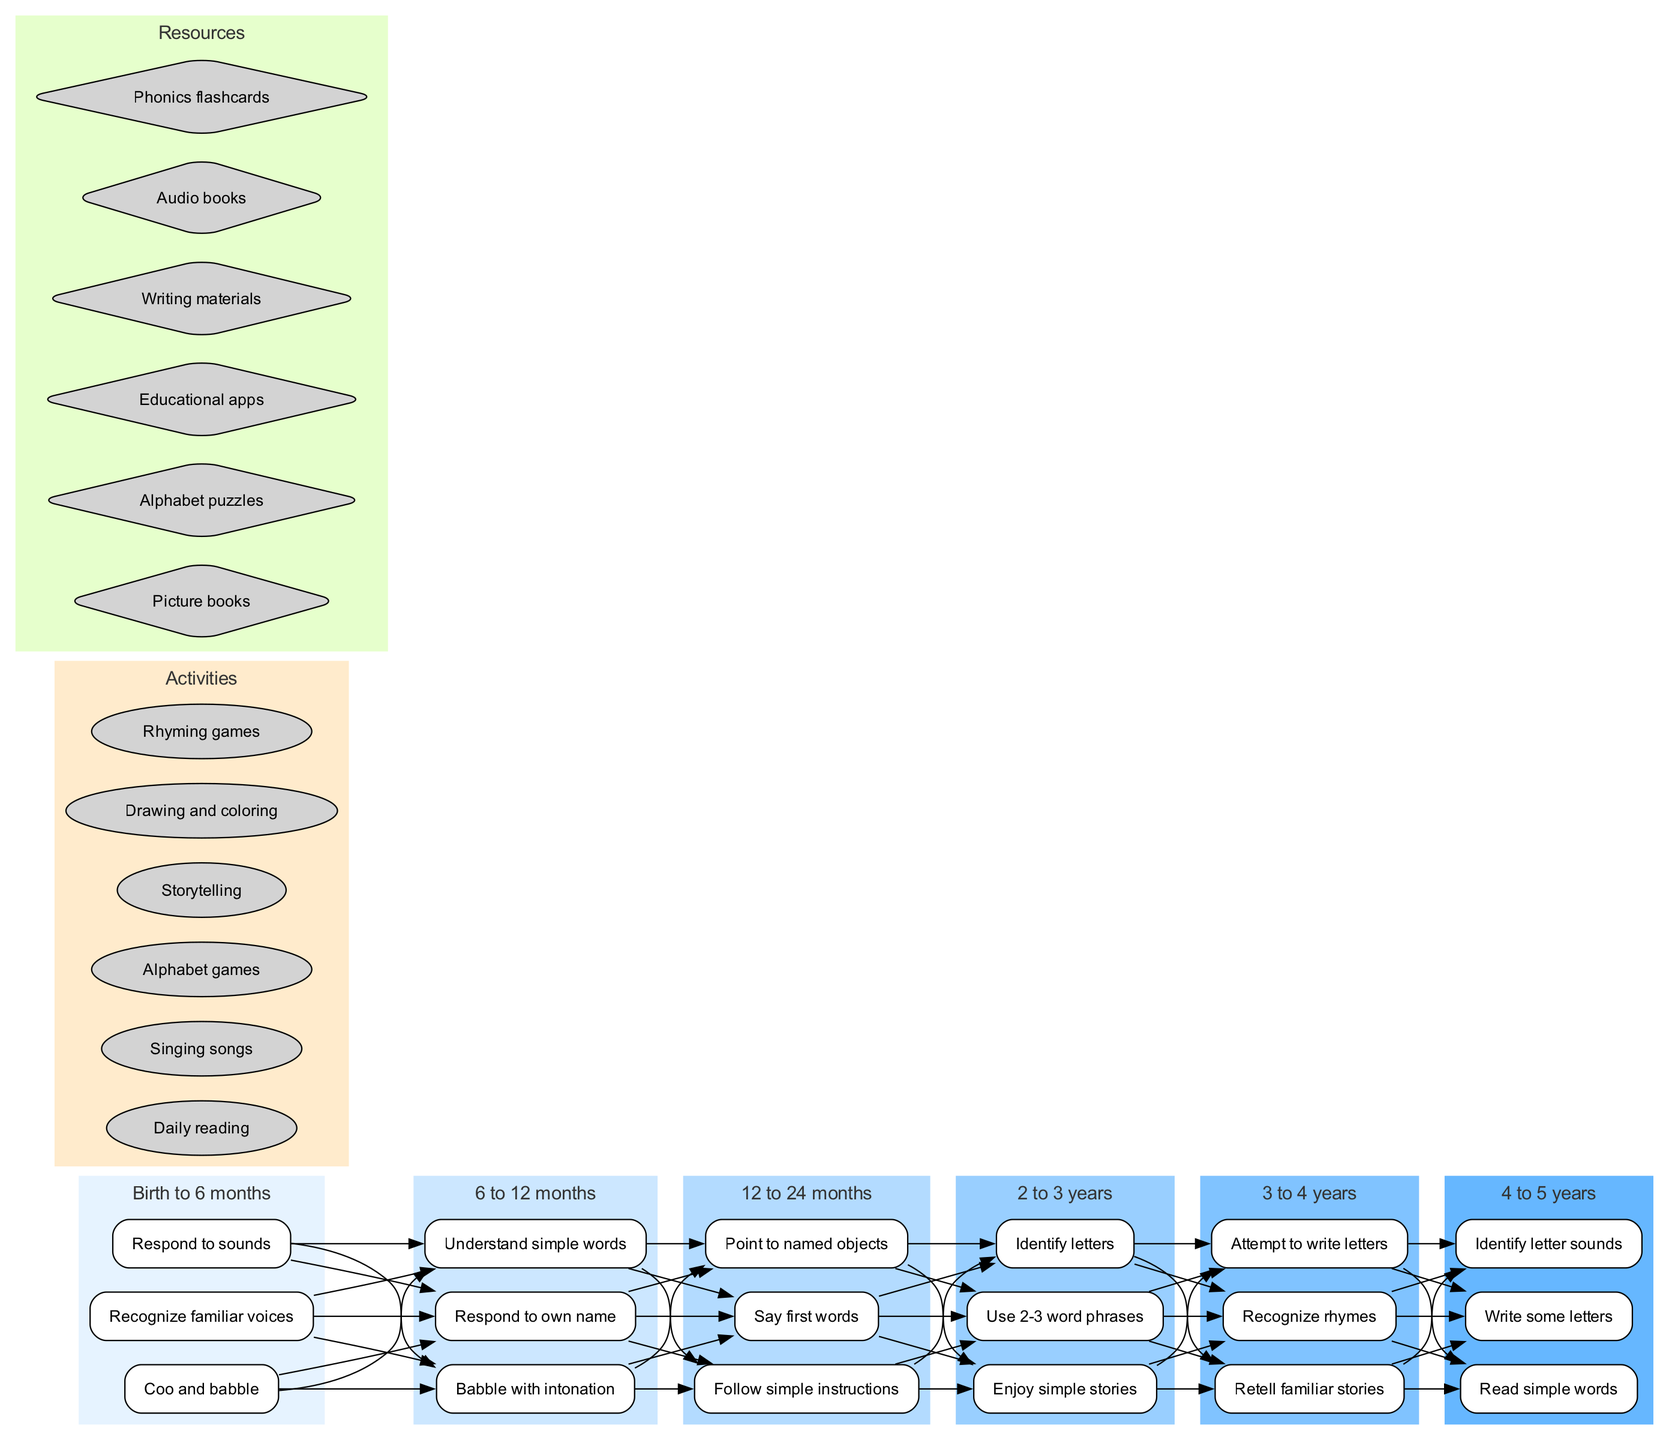What's the first skill listed in the "Birth to 6 months" stage? The first skill listed in the milestones for the "Birth to 6 months" stage is found in the corresponding cluster node specifically labeled for that stage, which indicates "Respond to sounds."
Answer: Respond to sounds How many milestones are outlined for the "3 to 4 years" stage? The "3 to 4 years" stage has three skills listed within its cluster, as indicated by the nodes for that stage in the diagram.
Answer: 3 Which stage involves "Say first words" as a milestone? By locating the milestone "Say first words," we can see it is part of the skills defined within the "12 to 24 months" stage in the diagram.
Answer: 12 to 24 months What is the relationship between "Enjoy simple stories" and "Retell familiar stories"? Both skills are part of consecutive stages, with "Enjoy simple stories" being in the "2 to 3 years" stage and "Retell familiar stories" in the "3 to 4 years" stage, representing the progression of skills as children learn to engage with stories.
Answer: Sequential progression How many activities are listed in total? The list of activities includes six nodes labeled with the corresponding activities, which is shown as a collection within their designated cluster in the diagram.
Answer: 6 Which resource is associated with the skill to "Identify letter sounds"? The skill "Identify letter sounds" belongs to the "4 to 5 years" stage, but the resources that support this skill include "Phonics flashcards," and these can be identified by examining the resources cluster in the diagram.
Answer: Phonics flashcards What is the last skill listed in the "4 to 5 years" stage? The last skill in the "4 to 5 years" stage is represented as "Read simple words," which is indicated by the position of the skill node within that stage in the diagram.
Answer: Read simple words What type of node represents the activities in this clinical pathway? The activities in the clinical pathway are represented by oval-shaped nodes, as specified in the diagram's configuration for the activities cluster.
Answer: Oval-shaped nodes How do "Singing songs" and "Rhyming games" relate to early literacy skills? Both activities, "Singing songs" and "Rhyming games," are featured in the same activities cluster, suggesting they contribute to the development of listening and phonetic skills, which are critical for early literacy.
Answer: They contribute to literacy development 